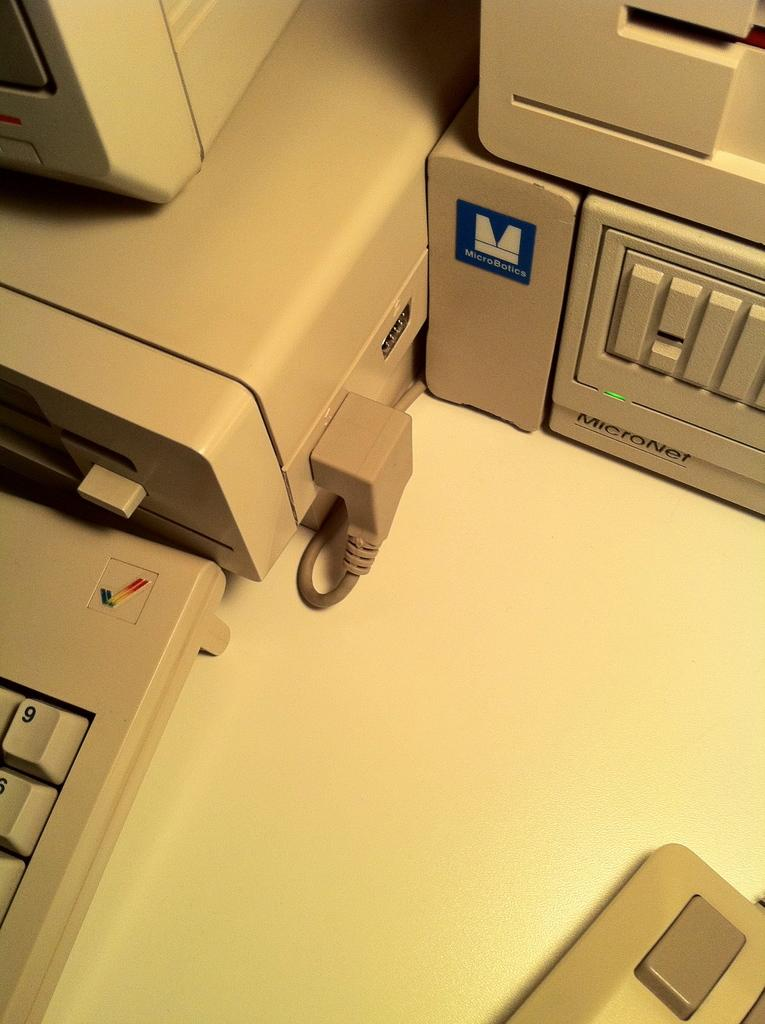<image>
Provide a brief description of the given image. Computer desktop on a table that is branded MicroNet. 